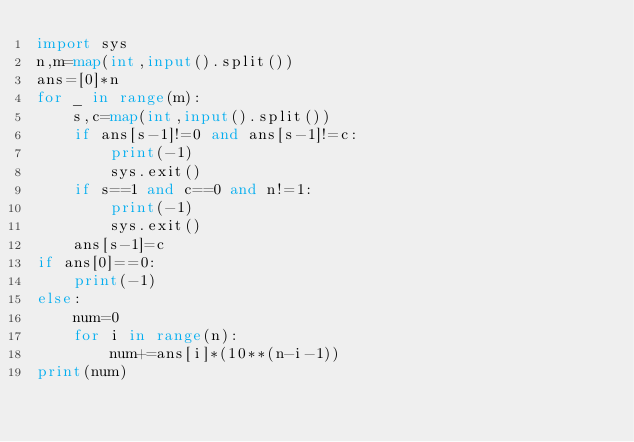<code> <loc_0><loc_0><loc_500><loc_500><_Python_>import sys
n,m=map(int,input().split())
ans=[0]*n
for _ in range(m):
    s,c=map(int,input().split())
    if ans[s-1]!=0 and ans[s-1]!=c:
        print(-1)
        sys.exit()
    if s==1 and c==0 and n!=1:
        print(-1)
        sys.exit()
    ans[s-1]=c
if ans[0]==0:
    print(-1)
else:
    num=0
    for i in range(n):
        num+=ans[i]*(10**(n-i-1))
print(num)</code> 